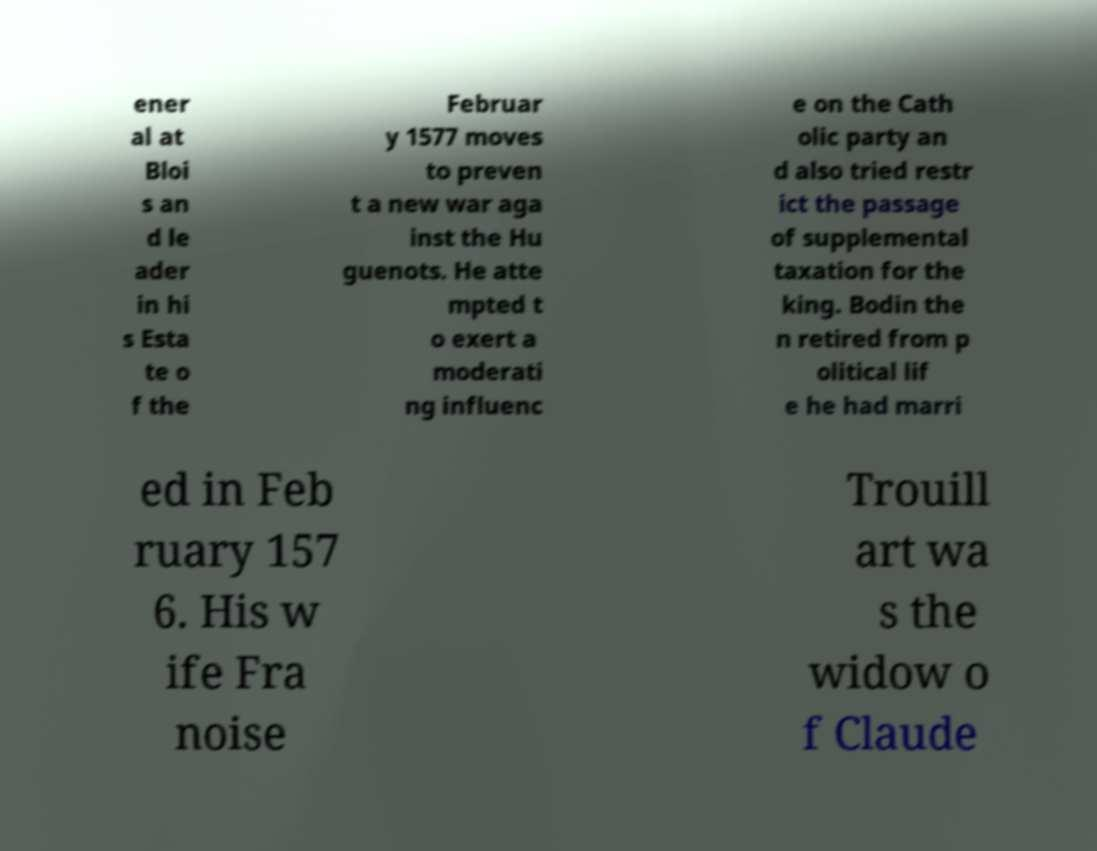What messages or text are displayed in this image? I need them in a readable, typed format. ener al at Bloi s an d le ader in hi s Esta te o f the Februar y 1577 moves to preven t a new war aga inst the Hu guenots. He atte mpted t o exert a moderati ng influenc e on the Cath olic party an d also tried restr ict the passage of supplemental taxation for the king. Bodin the n retired from p olitical lif e he had marri ed in Feb ruary 157 6. His w ife Fra noise Trouill art wa s the widow o f Claude 